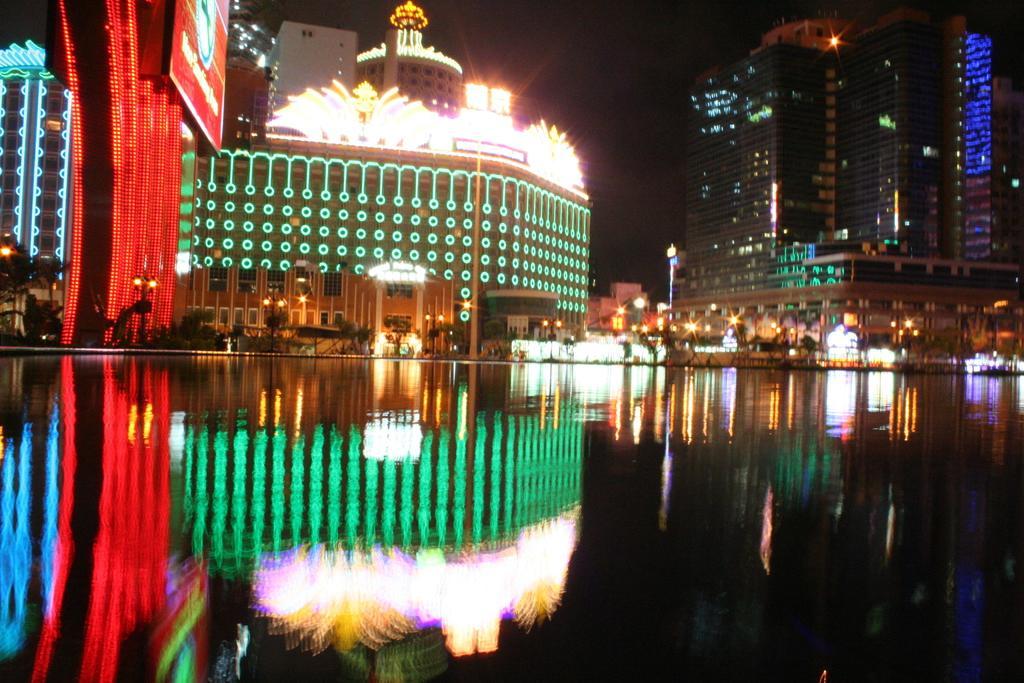Describe this image in one or two sentences. In this image we can see a group of buildings with lights, some poles, a large water body, trees and the sky. 